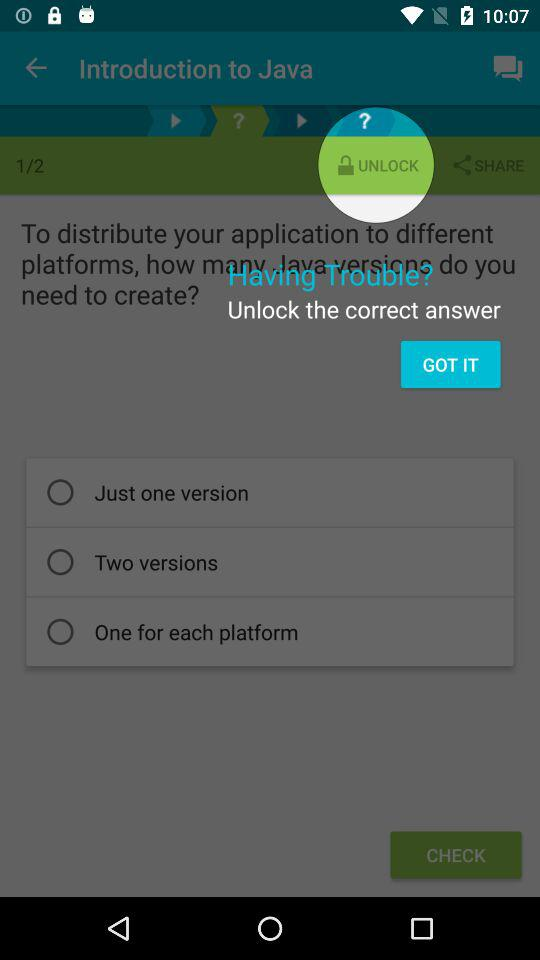How many options are there for the number of Java versions to create?
Answer the question using a single word or phrase. 3 